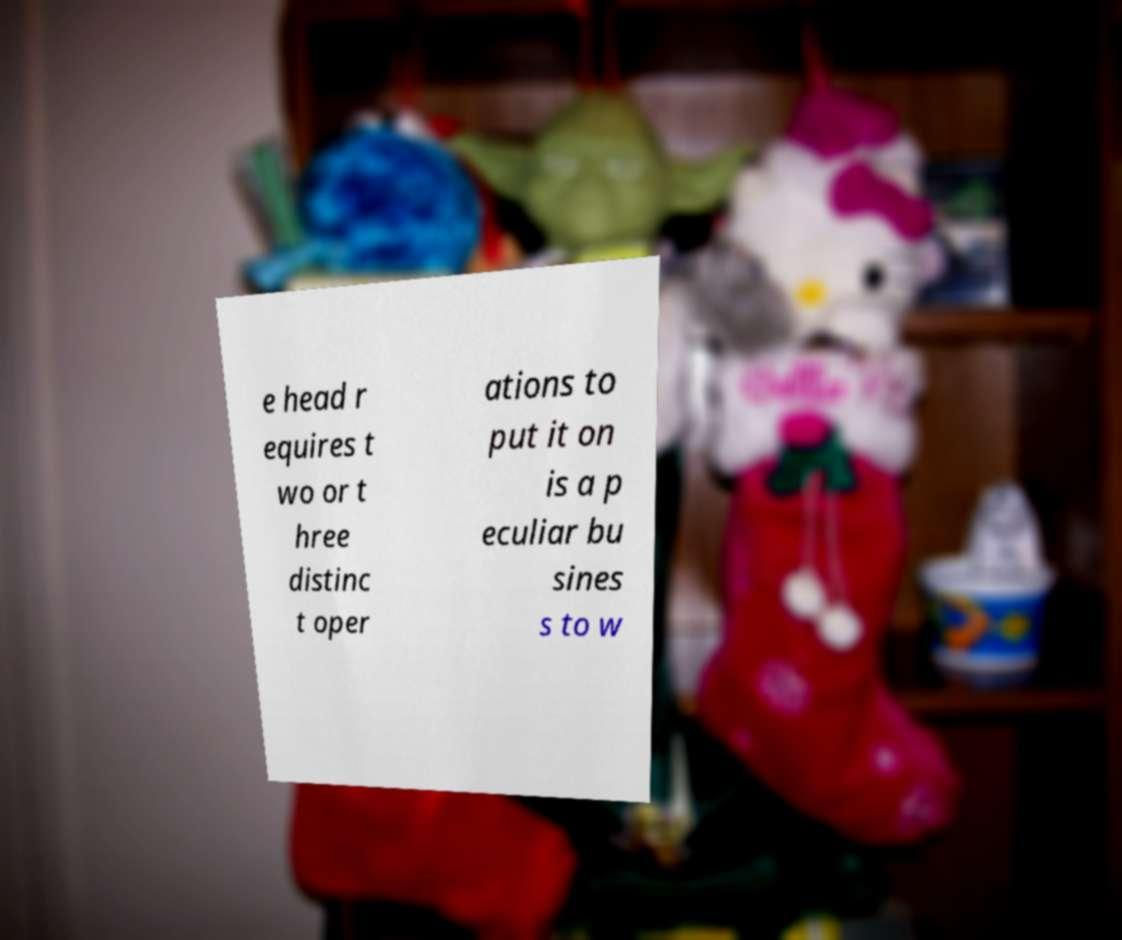Could you assist in decoding the text presented in this image and type it out clearly? e head r equires t wo or t hree distinc t oper ations to put it on is a p eculiar bu sines s to w 